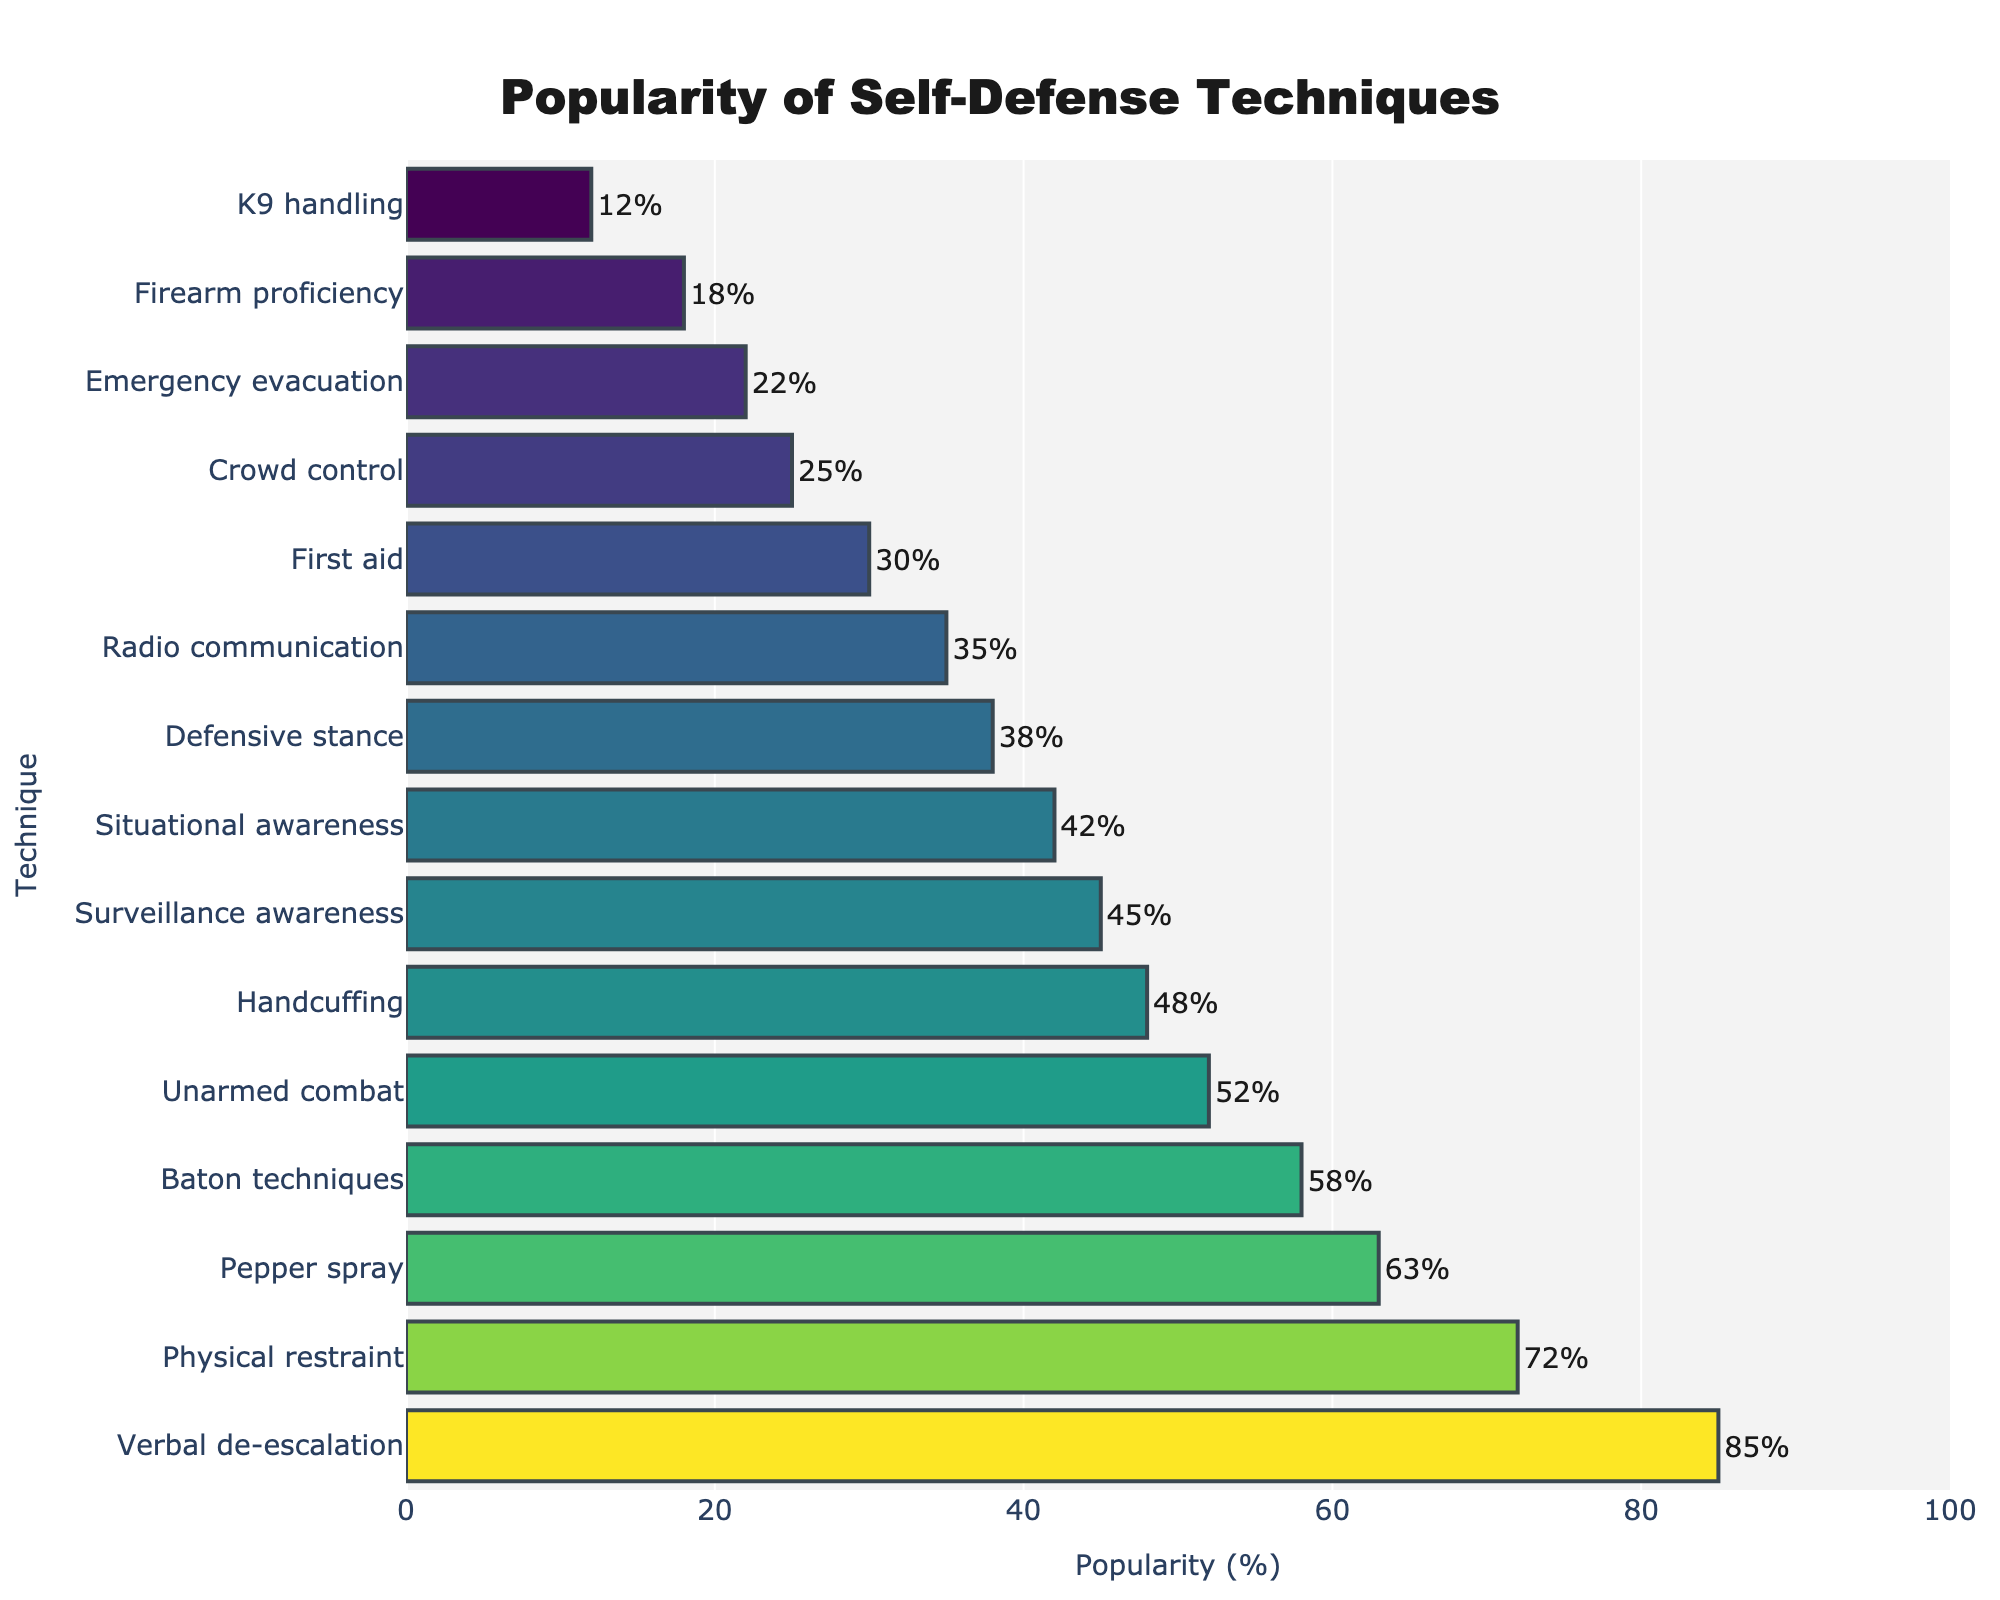What is the most popular self-defense technique among security professionals? The bar with the highest value represents the most popular technique. In this case, it is Verbal de-escalation with a popularity of 85%.
Answer: Verbal de-escalation Which technique has a higher popularity: Pepper spray or Baton techniques? Compare the lengths of the bars for Pepper spray and Baton techniques. Pepper spray has a popularity of 63%, while Baton techniques have a popularity of 58%.
Answer: Pepper spray What is the combined popularity of Physical restraint and Unarmed combat techniques? Add the popularity percentages of Physical restraint (72%) and Unarmed combat (52%), the total is 72 + 52 = 124%.
Answer: 124% Which technique has a lower popularity: First aid or Crowd control? Compare the bar values for First aid and Crowd control. First aid has a popularity of 30%, while Crowd control has a popularity of 25%.
Answer: Crowd control What is the average popularity of the top 3 techniques? Sum the popularity percentages of the top 3 techniques (Verbal de-escalation: 85%, Physical restraint: 72%, Pepper spray: 63%) and divide by 3: (85 + 72 + 63) / 3 = 73.33%.
Answer: 73.33% How does the popularity of Situational awareness compare to Surveillance awareness? Compare the lengths of the bars for Situational awareness and Surveillance awareness. Situational awareness has a popularity of 42%, while Surveillance awareness has a popularity of 45%.
Answer: Surveillance awareness What percentage of the techniques have a popularity below 40%? Count the number of techniques with popularity below 40% and divide by the total number of techniques. There are 6 (Defensive stance, Radio communication, First aid, Crowd control, Emergency evacuation, Firearm proficiency, K9 handling) out of 15, so 6 / 15 * 100 = 40%.
Answer: 40% Which technique is just below Physical restraint in popularity? Look for the technique with the next lower bar value below Physical restraint (72%). Pepper spray, with a popularity of 63%, is just below it.
Answer: Pepper spray What is the difference in popularity between Defensive stance and Radio communication? Subtract the popularity percentage of Radio communication (35%) from that of Defensive stance (38%): 38 - 35 = 3%.
Answer: 3% How many techniques have a popularity above 50%? Count the number of techniques with popularity percentages above 50%. There are 5 (Verbal de-escalation, Physical restraint, Pepper spray, Baton techniques, Unarmed combat).
Answer: 5 